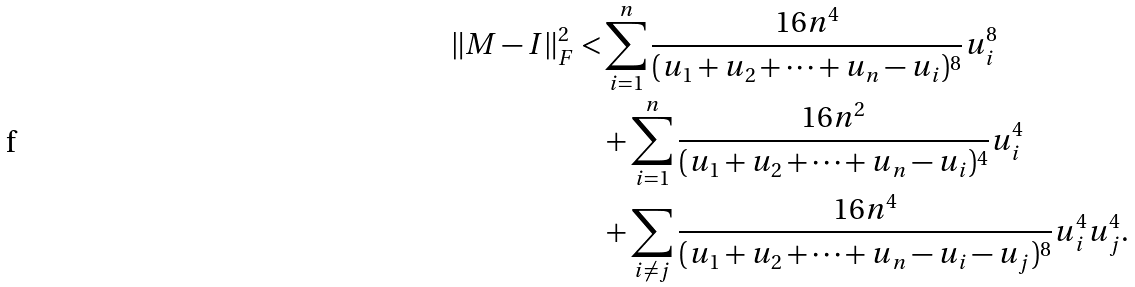Convert formula to latex. <formula><loc_0><loc_0><loc_500><loc_500>\| M - I \| _ { F } ^ { 2 } < & \sum _ { i = 1 } ^ { n } \frac { 1 6 n ^ { 4 } } { ( u _ { 1 } + u _ { 2 } + \dots + u _ { n } - u _ { i } ) ^ { 8 } } u _ { i } ^ { 8 } \\ & + \sum _ { i = 1 } ^ { n } \frac { 1 6 n ^ { 2 } } { ( u _ { 1 } + u _ { 2 } + \dots + u _ { n } - u _ { i } ) ^ { 4 } } u _ { i } ^ { 4 } \\ & + \sum _ { i \neq j } \frac { 1 6 n ^ { 4 } } { ( u _ { 1 } + u _ { 2 } + \dots + u _ { n } - u _ { i } - u _ { j } ) ^ { 8 } } u _ { i } ^ { 4 } u _ { j } ^ { 4 } .</formula> 